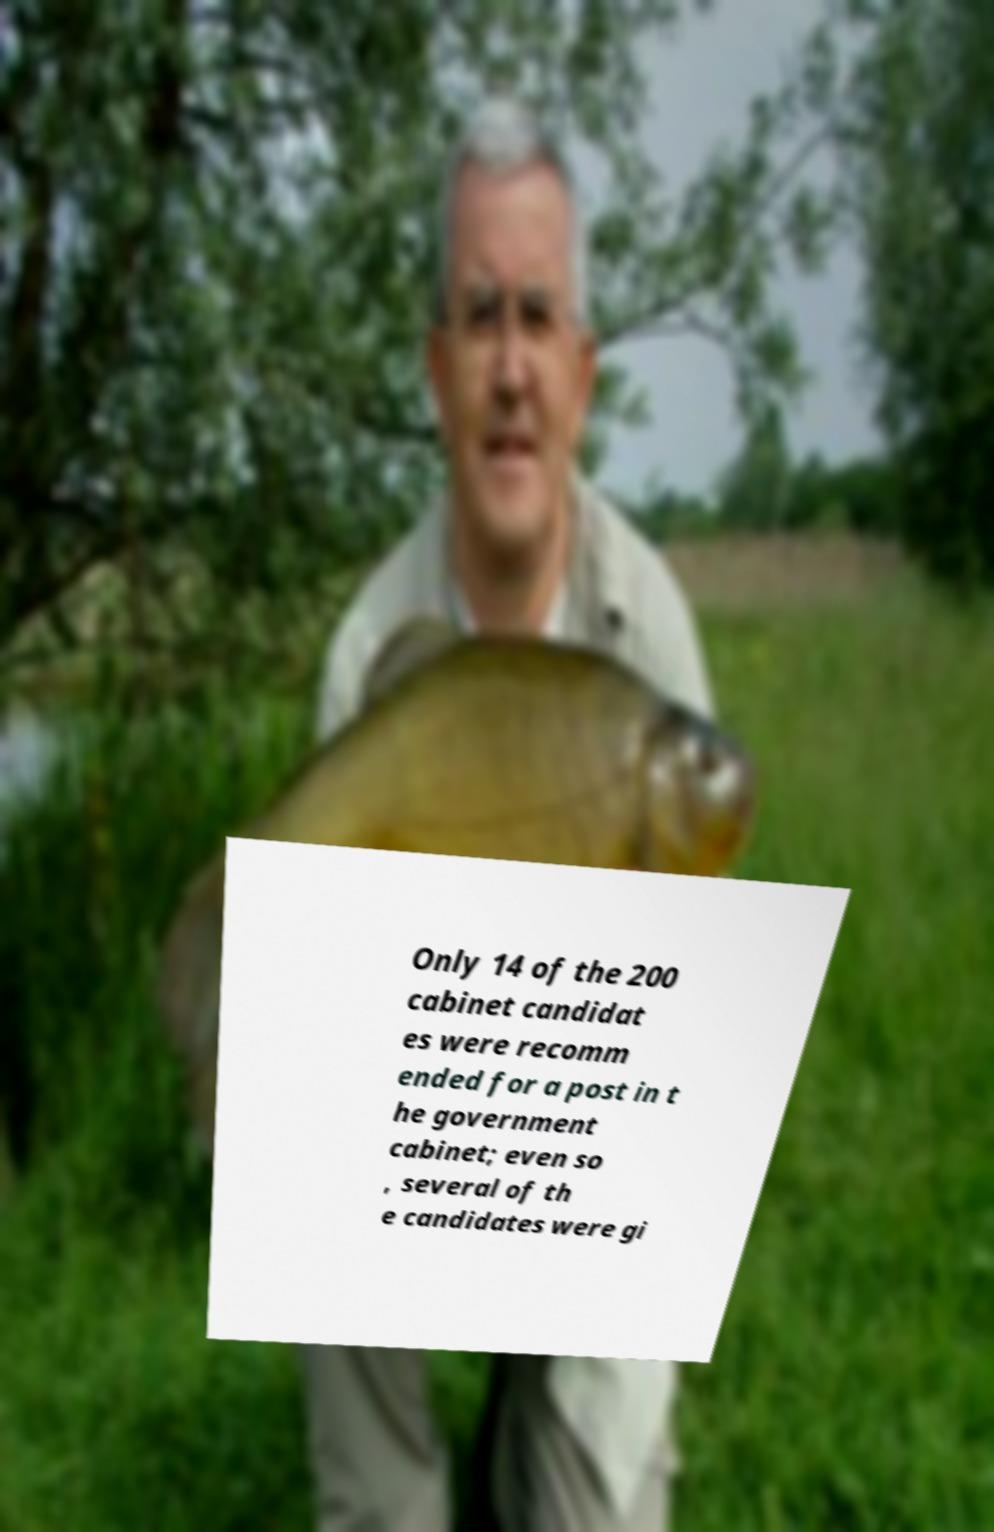Could you extract and type out the text from this image? Only 14 of the 200 cabinet candidat es were recomm ended for a post in t he government cabinet; even so , several of th e candidates were gi 